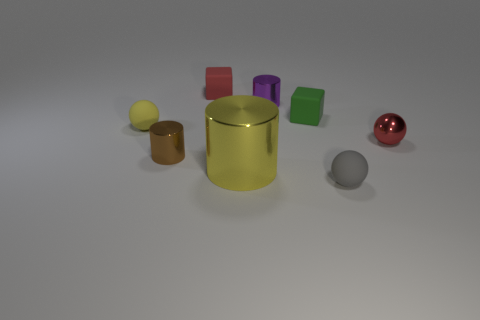Is there any other thing that is the same size as the yellow metallic cylinder?
Provide a short and direct response. No. Is the yellow rubber thing the same shape as the tiny red metallic thing?
Offer a very short reply. Yes. What number of big objects are red matte things or gray balls?
Provide a short and direct response. 0. What color is the big object?
Make the answer very short. Yellow. What is the shape of the tiny red thing in front of the tiny metal cylinder that is behind the red sphere?
Offer a very short reply. Sphere. Is there a tiny brown object that has the same material as the big thing?
Your answer should be compact. Yes. Is the size of the red thing that is on the right side of the gray matte thing the same as the green block?
Offer a very short reply. Yes. What number of gray objects are either tiny objects or cubes?
Your answer should be compact. 1. What is the material of the red object that is behind the small yellow sphere?
Provide a short and direct response. Rubber. How many yellow things are in front of the tiny cylinder left of the small purple metallic object?
Provide a succinct answer. 1. 